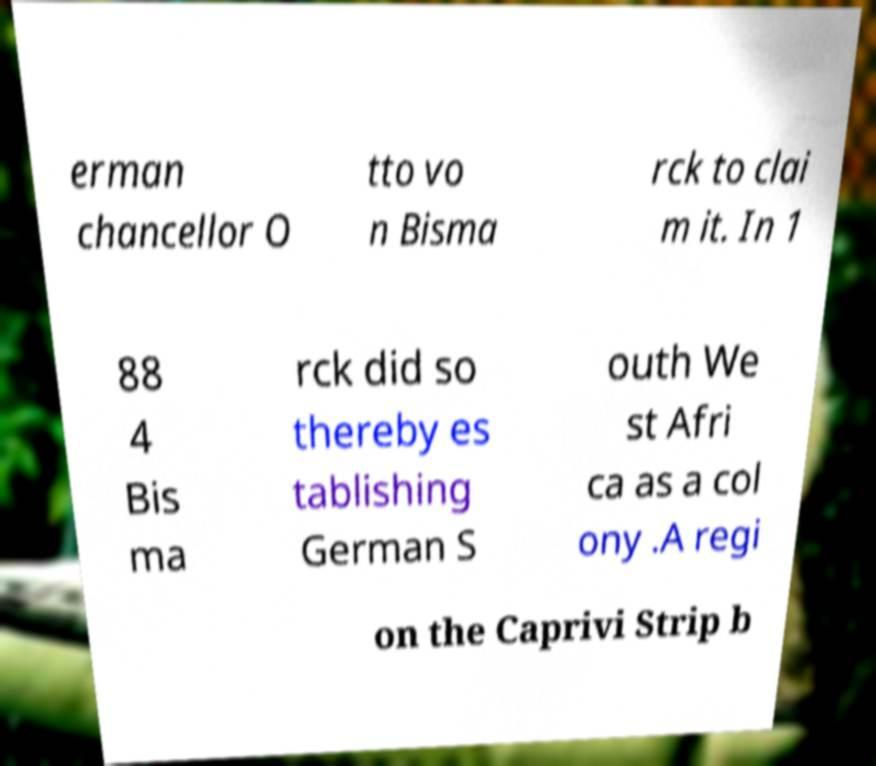What messages or text are displayed in this image? I need them in a readable, typed format. erman chancellor O tto vo n Bisma rck to clai m it. In 1 88 4 Bis ma rck did so thereby es tablishing German S outh We st Afri ca as a col ony .A regi on the Caprivi Strip b 